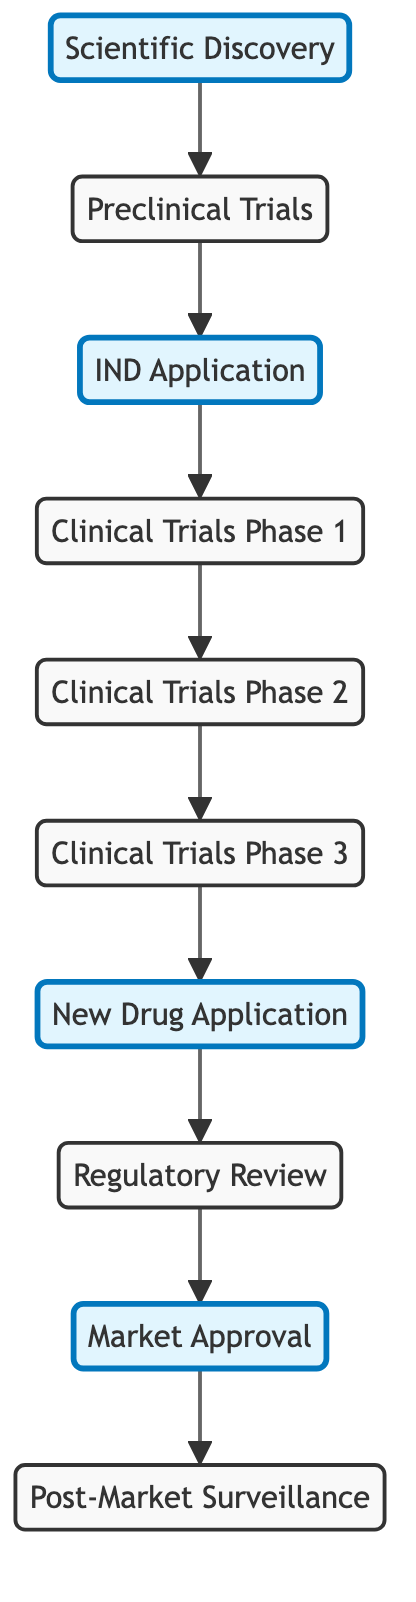What is the first step in the regulatory approval process? The first step in the diagram is the "Scientific Discovery", which is the initial stage of the regulatory approval process.
Answer: Scientific Discovery How many phases are there in clinical trials before applying for a New Drug Application? The diagram shows three phases of clinical trials: Phase 1, Phase 2, and Phase 3, which must be completed before the NDA.
Answer: Three Which node represents the application made to regulatory authorities for new drug approval? The "New Drug Application (NDA)" node represents this application in the regulatory approval process, as indicated in the diagram.
Answer: New Drug Application What comes immediately after the Regulatory Review phase? The node directly following "Regulatory Review" in the diagram is "Market Approval", indicating the next step in the process.
Answer: Market Approval What is the final stage in the regulatory approval process? The last node in the flow is "Post-Market Surveillance", which indicates ongoing monitoring after market approval is granted.
Answer: Post-Market Surveillance Which trial phase directly precedes Clinical Trials Phase 3? Referring to the diagram arrow connections, "Clinical Trials Phase 2" comes directly before "Clinical Trials Phase 3".
Answer: Clinical Trials Phase 2 How many edges are in total in this directed graph? By counting the connections in the edges section of the diagram, there are 9 directed edges between the nodes.
Answer: Nine What is the relationship between the IND Application and Clinical Trials Phase 1? The IND Application leads directly to Clinical Trials Phase 1, as shown by the edge connecting these two nodes.
Answer: Leads to Which phases occur after the completion of the preclinical trials? The phases occurring after preclinical trials are the IND Application followed by Clinical Trials Phase 1, then Phase 2, and finally Phase 3.
Answer: IND Application, Clinical Trials Phase 1 What is the connection that indicates the end of the approval process? The connection leading from "Approval" to "Post-Market Surveillance" indicates the conclusion of the initial approval process and the beginning of monitoring.
Answer: Approval to Post-Market Surveillance 